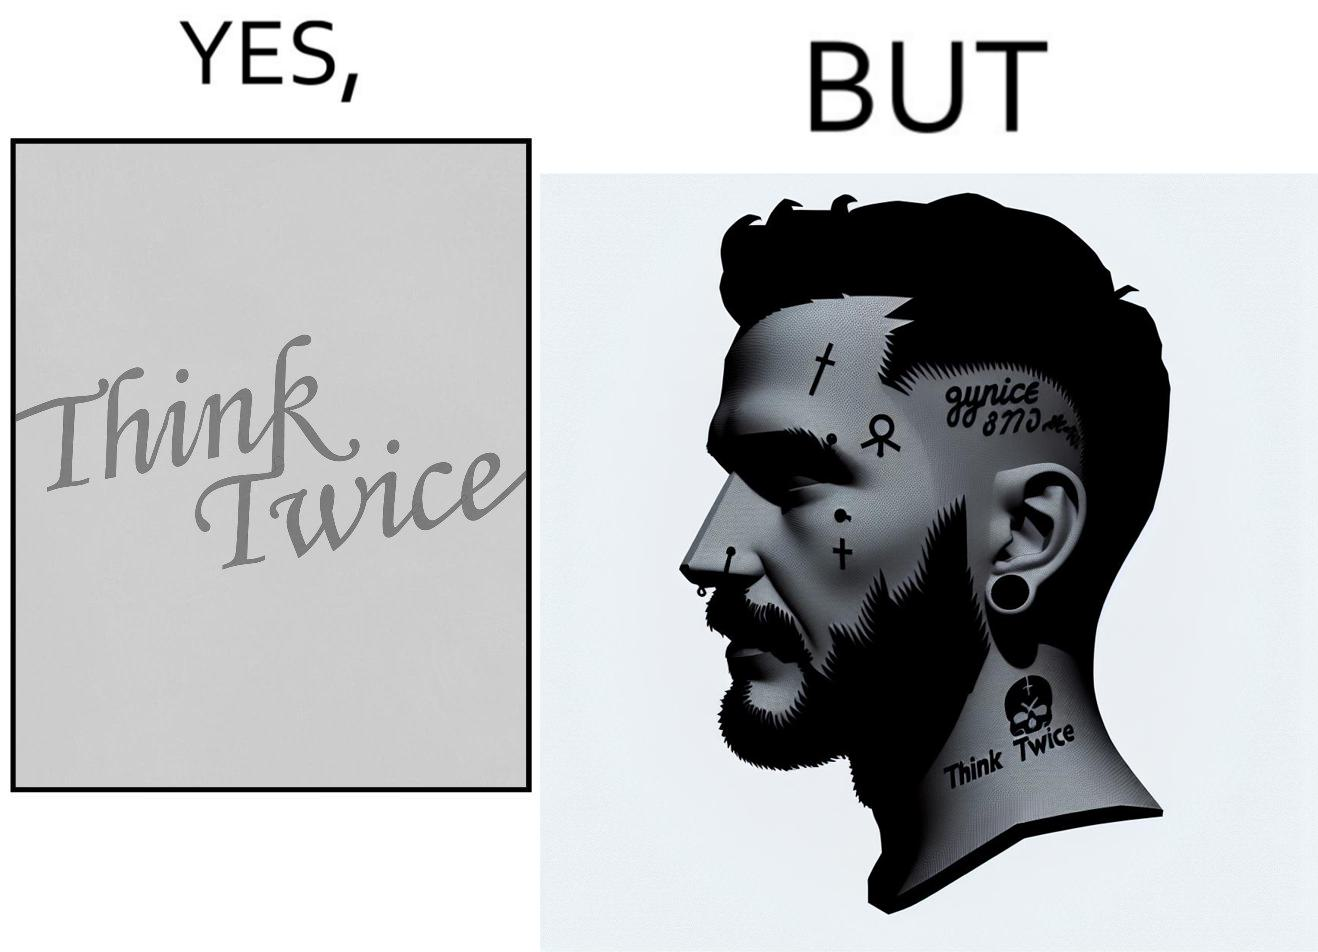Describe the satirical element in this image. The image is funny because even thought the tattoo on the face of the man says "think twice", the man did not think twice before getting the tattoo on his forehead. 